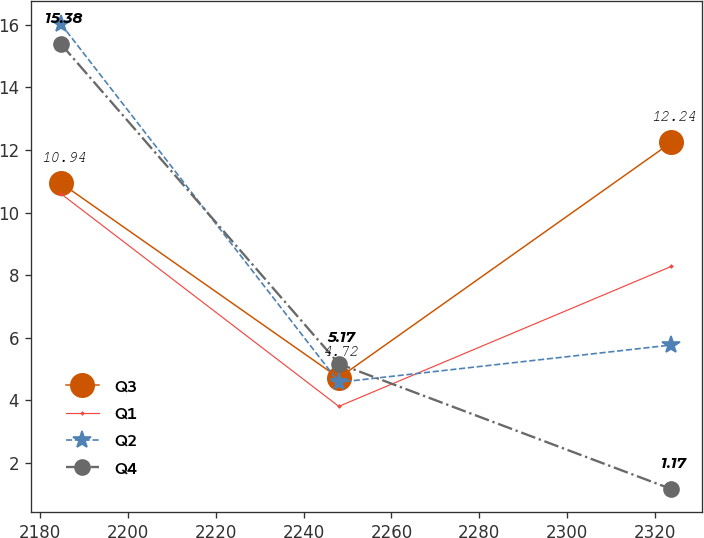Convert chart to OTSL. <chart><loc_0><loc_0><loc_500><loc_500><line_chart><ecel><fcel>Q3<fcel>Q1<fcel>Q2<fcel>Q4<nl><fcel>2184.76<fcel>10.94<fcel>10.6<fcel>16.02<fcel>15.38<nl><fcel>2248.03<fcel>4.72<fcel>3.81<fcel>4.58<fcel>5.17<nl><fcel>2323.74<fcel>12.24<fcel>8.28<fcel>5.77<fcel>1.17<nl></chart> 